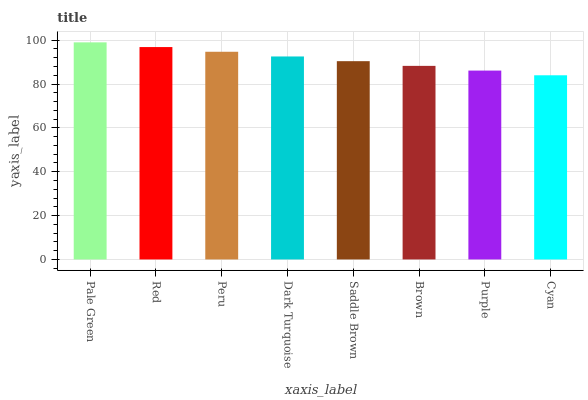Is Cyan the minimum?
Answer yes or no. Yes. Is Pale Green the maximum?
Answer yes or no. Yes. Is Red the minimum?
Answer yes or no. No. Is Red the maximum?
Answer yes or no. No. Is Pale Green greater than Red?
Answer yes or no. Yes. Is Red less than Pale Green?
Answer yes or no. Yes. Is Red greater than Pale Green?
Answer yes or no. No. Is Pale Green less than Red?
Answer yes or no. No. Is Dark Turquoise the high median?
Answer yes or no. Yes. Is Saddle Brown the low median?
Answer yes or no. Yes. Is Pale Green the high median?
Answer yes or no. No. Is Red the low median?
Answer yes or no. No. 